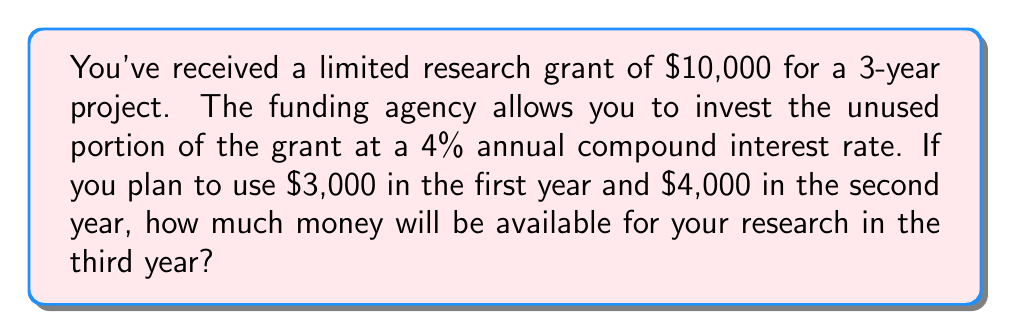Teach me how to tackle this problem. Let's approach this step-by-step:

1) Initial amount: $10,000

2) After the first year:
   - Used amount: $3,000
   - Remaining: $10,000 - $3,000 = $7,000
   - This $7,000 will earn interest for 2 years

3) Calculate the amount after 2 years of compound interest:
   $$A = P(1 + r)^n$$
   Where:
   $A$ = final amount
   $P$ = principal (initial investment)
   $r$ = annual interest rate (as a decimal)
   $n$ = number of years

   $$A = 7000(1 + 0.04)^2 = 7000(1.04)^2 = 7000(1.0816) = 7571.20$$

4) After the second year:
   - Available: $7571.20
   - Used amount: $4,000
   - Remaining: $7571.20 - $4000 = $3571.20
   - This $3571.20 will earn interest for 1 more year

5) Calculate the final amount after 1 more year of compound interest:
   $$A = 3571.20(1 + 0.04)^1 = 3571.20(1.04) = 3714.05$$

Therefore, $3714.05 will be available for research in the third year.
Answer: $3714.05 